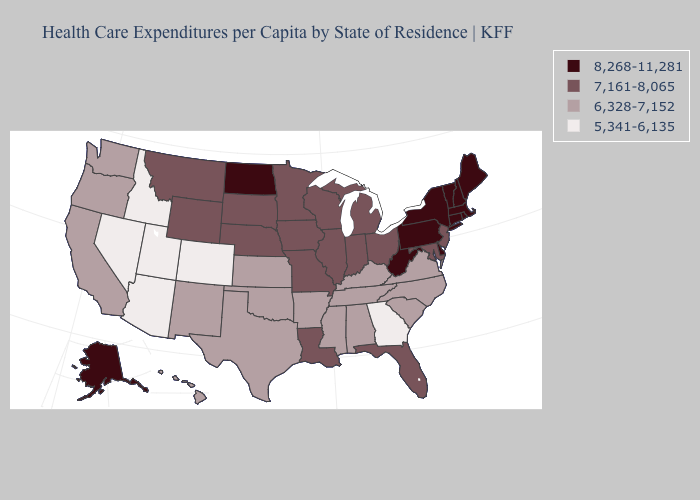What is the value of Ohio?
Keep it brief. 7,161-8,065. Which states have the lowest value in the West?
Write a very short answer. Arizona, Colorado, Idaho, Nevada, Utah. What is the highest value in the Northeast ?
Quick response, please. 8,268-11,281. What is the value of Missouri?
Give a very brief answer. 7,161-8,065. What is the value of Maine?
Quick response, please. 8,268-11,281. Name the states that have a value in the range 6,328-7,152?
Short answer required. Alabama, Arkansas, California, Hawaii, Kansas, Kentucky, Mississippi, New Mexico, North Carolina, Oklahoma, Oregon, South Carolina, Tennessee, Texas, Virginia, Washington. Name the states that have a value in the range 8,268-11,281?
Answer briefly. Alaska, Connecticut, Delaware, Maine, Massachusetts, New Hampshire, New York, North Dakota, Pennsylvania, Rhode Island, Vermont, West Virginia. What is the lowest value in states that border Wyoming?
Short answer required. 5,341-6,135. What is the value of Michigan?
Answer briefly. 7,161-8,065. Does the map have missing data?
Quick response, please. No. How many symbols are there in the legend?
Be succinct. 4. Does Texas have a lower value than North Carolina?
Be succinct. No. Name the states that have a value in the range 5,341-6,135?
Give a very brief answer. Arizona, Colorado, Georgia, Idaho, Nevada, Utah. Does Nevada have the highest value in the USA?
Write a very short answer. No. Name the states that have a value in the range 5,341-6,135?
Quick response, please. Arizona, Colorado, Georgia, Idaho, Nevada, Utah. 